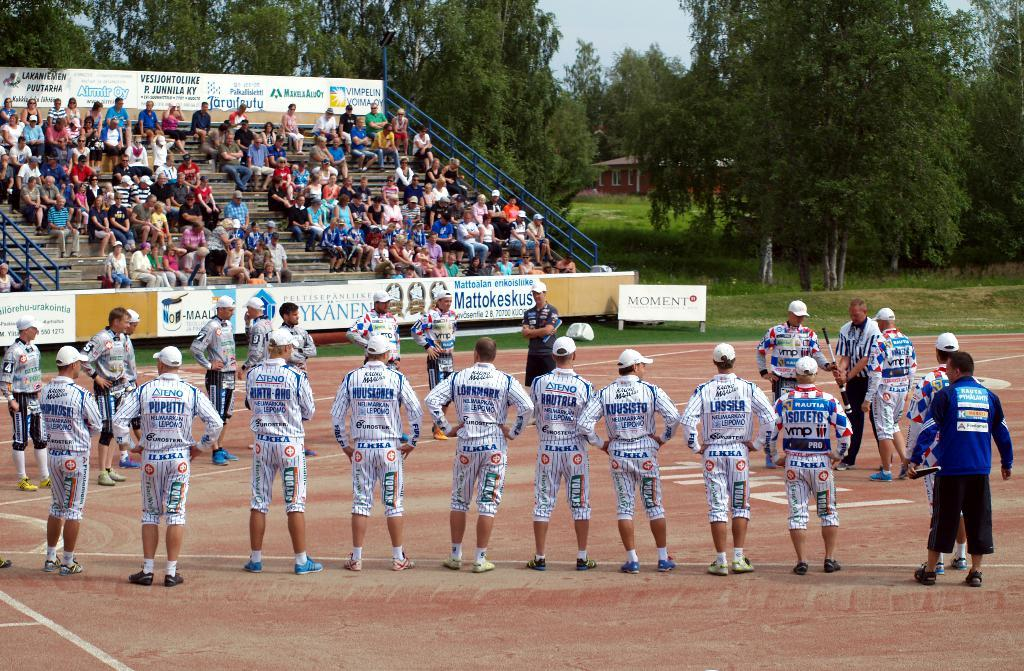<image>
Give a short and clear explanation of the subsequent image. A team of ball players stand across from the bleachers and a billboard for Moment. 